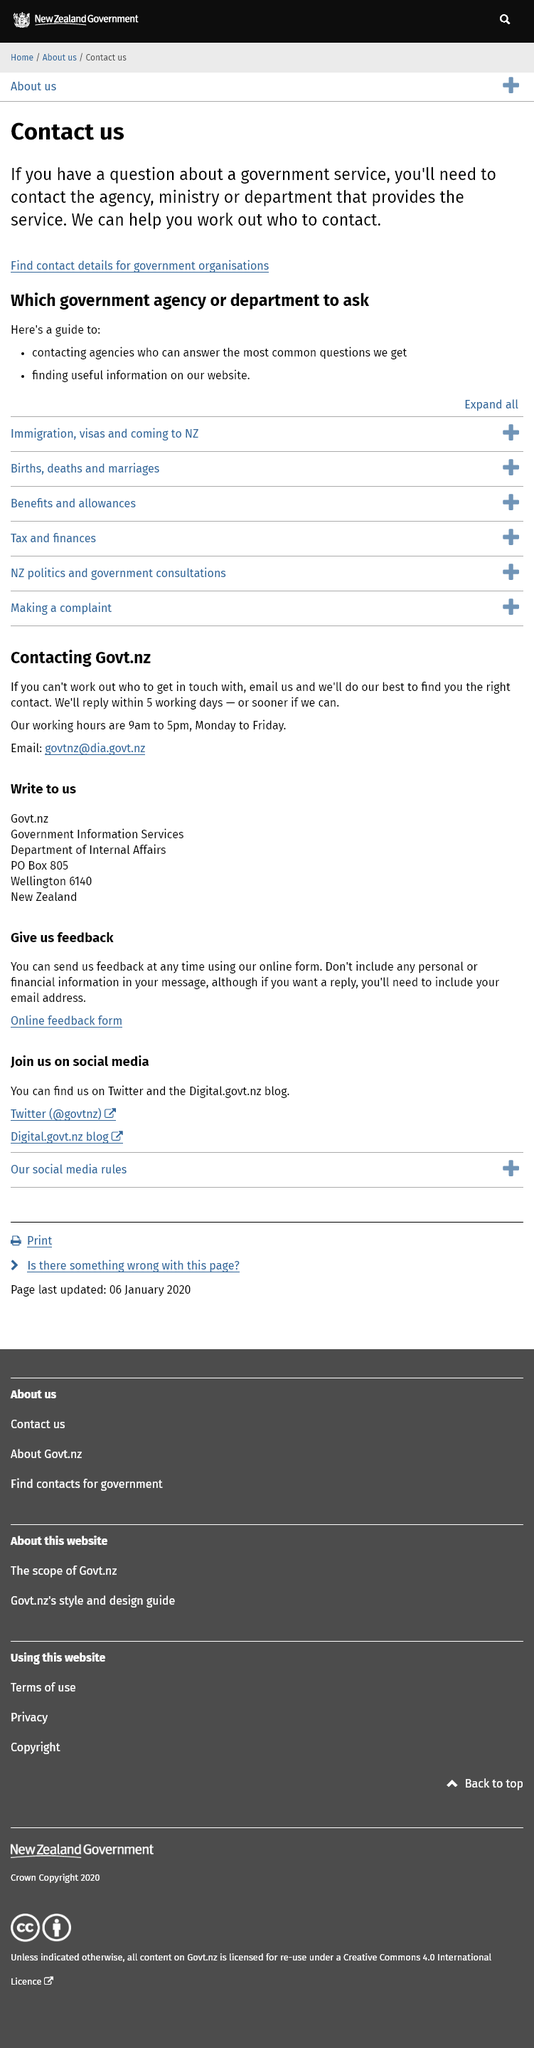Give some essential details in this illustration. Yes, there is a link to find the contact details for government organizations. If one has a query regarding a government service, they should contact the relevant agency, ministry or department to obtain a satisfactory response. The guide assists in contacting agencies that can provide answers to frequently asked questions and in finding valuable information on their website. 